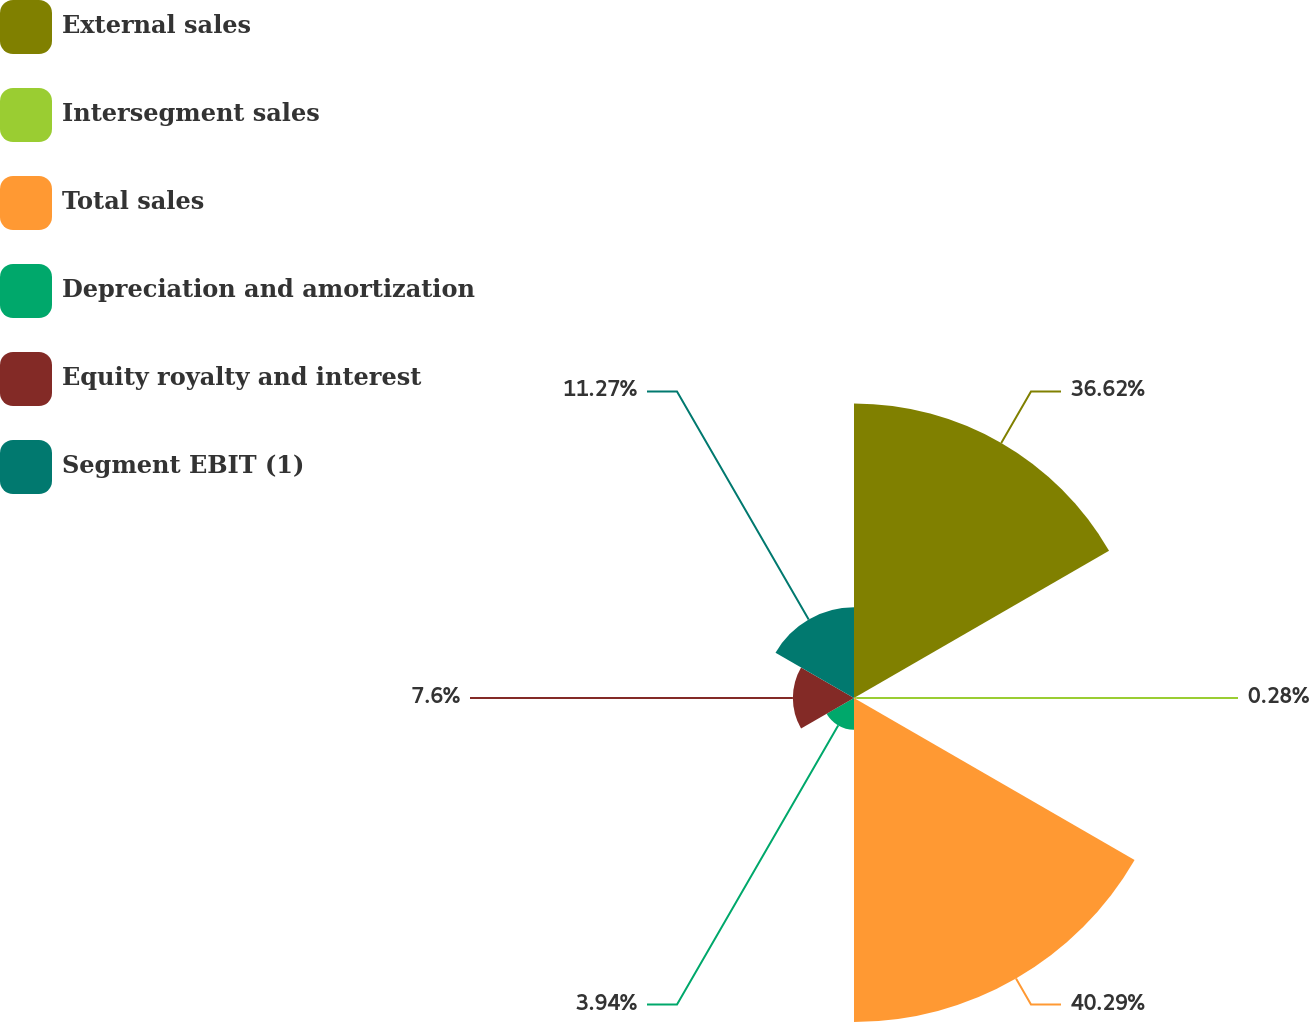<chart> <loc_0><loc_0><loc_500><loc_500><pie_chart><fcel>External sales<fcel>Intersegment sales<fcel>Total sales<fcel>Depreciation and amortization<fcel>Equity royalty and interest<fcel>Segment EBIT (1)<nl><fcel>36.62%<fcel>0.28%<fcel>40.29%<fcel>3.94%<fcel>7.6%<fcel>11.27%<nl></chart> 